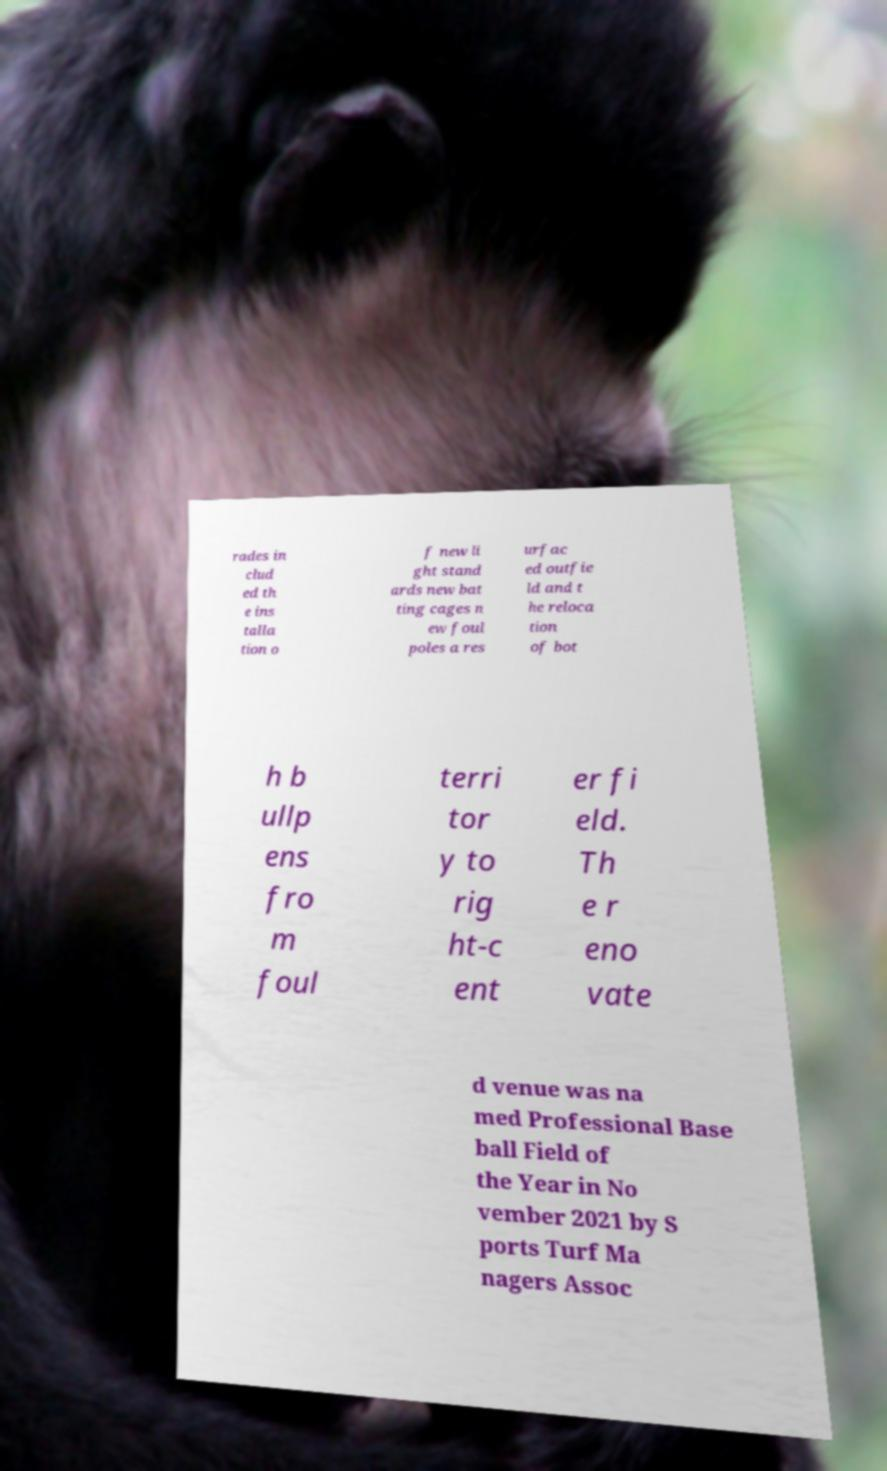Can you accurately transcribe the text from the provided image for me? rades in clud ed th e ins talla tion o f new li ght stand ards new bat ting cages n ew foul poles a res urfac ed outfie ld and t he reloca tion of bot h b ullp ens fro m foul terri tor y to rig ht-c ent er fi eld. Th e r eno vate d venue was na med Professional Base ball Field of the Year in No vember 2021 by S ports Turf Ma nagers Assoc 